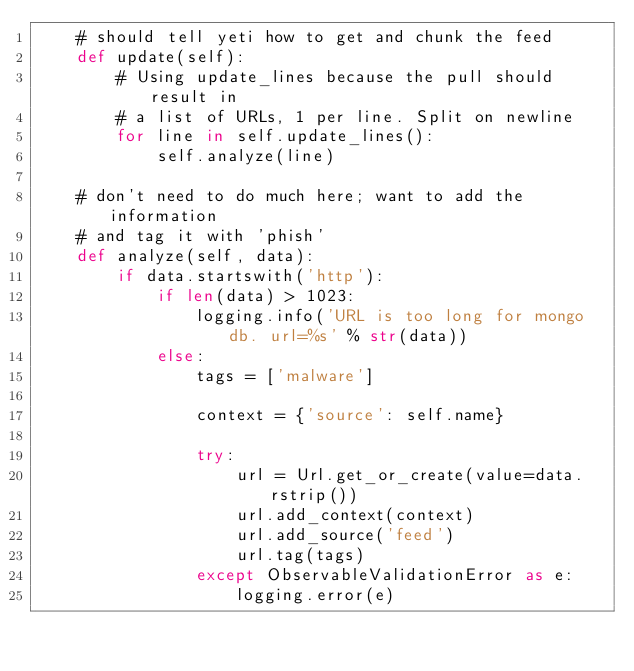Convert code to text. <code><loc_0><loc_0><loc_500><loc_500><_Python_>    # should tell yeti how to get and chunk the feed
    def update(self):
        # Using update_lines because the pull should result in
        # a list of URLs, 1 per line. Split on newline
        for line in self.update_lines():
            self.analyze(line)

    # don't need to do much here; want to add the information
    # and tag it with 'phish'
    def analyze(self, data):
        if data.startswith('http'):
            if len(data) > 1023:
                logging.info('URL is too long for mongo db. url=%s' % str(data))
            else:
                tags = ['malware']

                context = {'source': self.name}

                try:
                    url = Url.get_or_create(value=data.rstrip())
                    url.add_context(context)
                    url.add_source('feed')
                    url.tag(tags)
                except ObservableValidationError as e:
                    logging.error(e)
</code> 